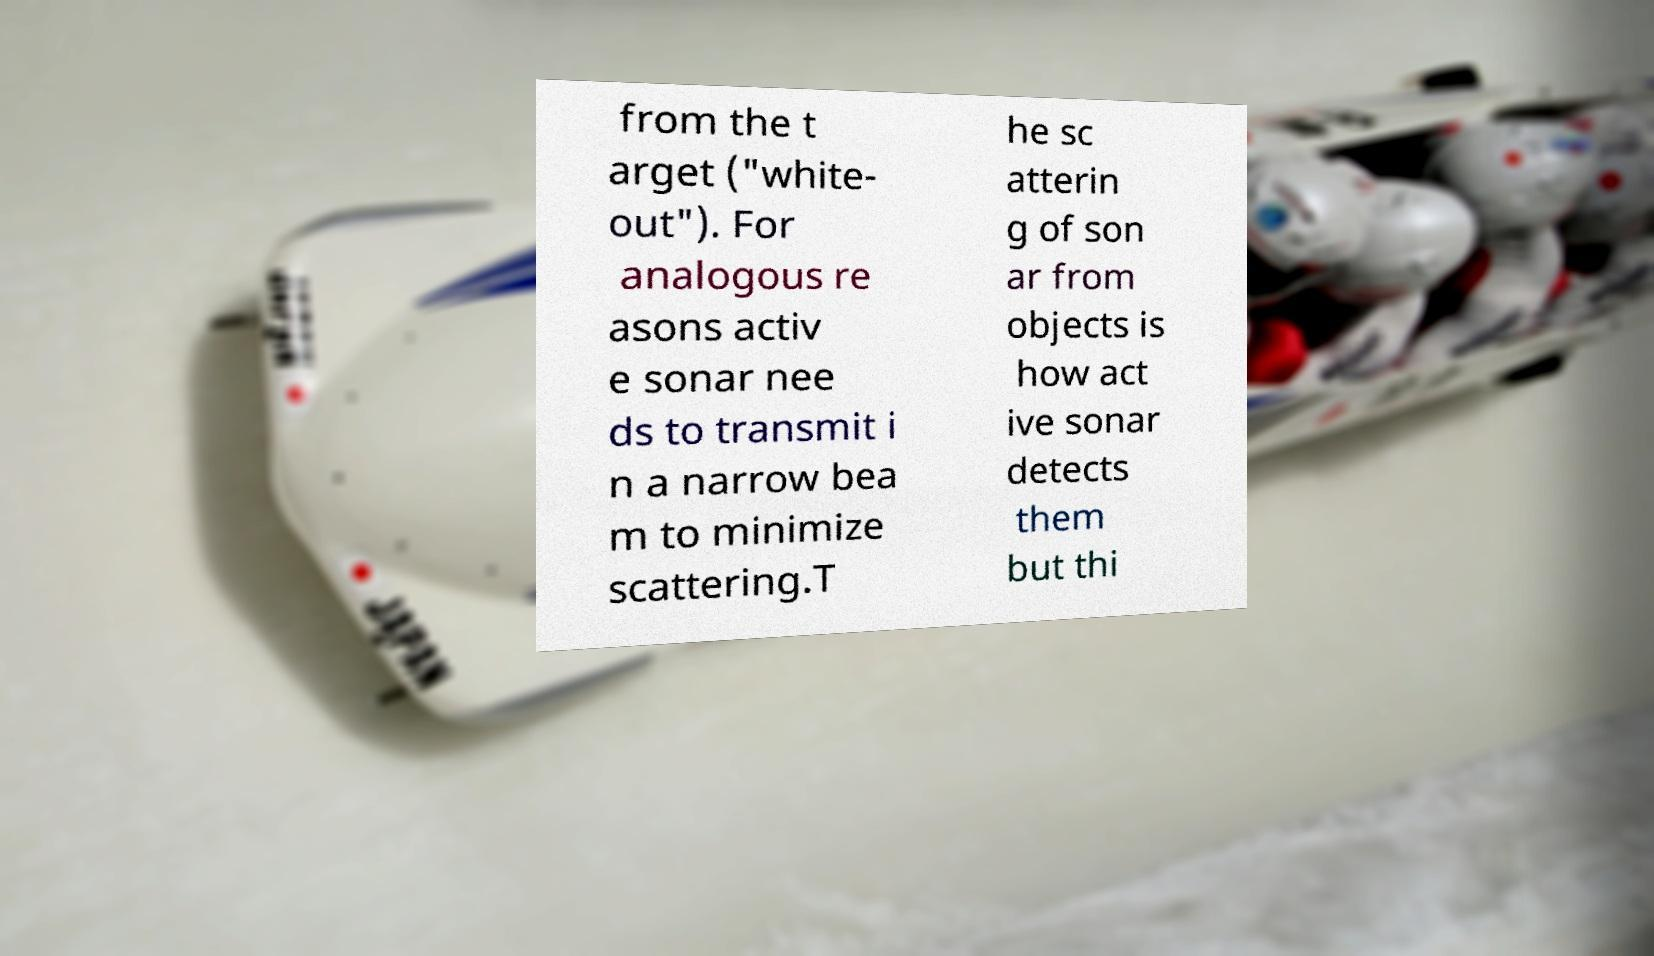Could you extract and type out the text from this image? from the t arget ("white- out"). For analogous re asons activ e sonar nee ds to transmit i n a narrow bea m to minimize scattering.T he sc atterin g of son ar from objects is how act ive sonar detects them but thi 